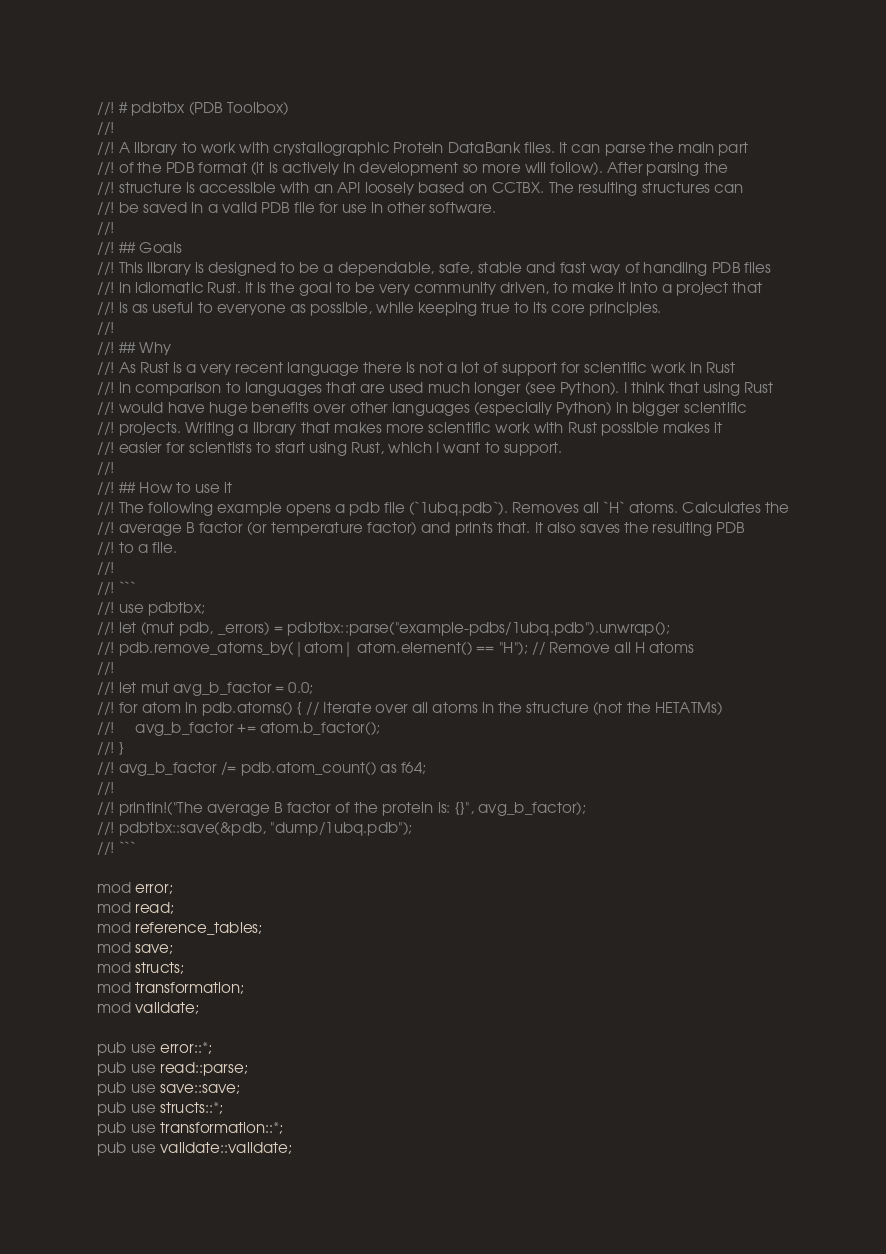<code> <loc_0><loc_0><loc_500><loc_500><_Rust_>//! # pdbtbx (PDB Toolbox)
//!
//! A library to work with crystallographic Protein DataBank files. It can parse the main part
//! of the PDB format (it is actively in development so more will follow). After parsing the
//! structure is accessible with an API loosely based on CCTBX. The resulting structures can
//! be saved in a valid PDB file for use in other software.
//!
//! ## Goals
//! This library is designed to be a dependable, safe, stable and fast way of handling PDB files
//! in idiomatic Rust. It is the goal to be very community driven, to make it into a project that
//! is as useful to everyone as possible, while keeping true to its core principles.
//!
//! ## Why
//! As Rust is a very recent language there is not a lot of support for scientific work in Rust
//! in comparison to languages that are used much longer (see Python). I think that using Rust
//! would have huge benefits over other languages (especially Python) in bigger scientific
//! projects. Writing a library that makes more scientific work with Rust possible makes it
//! easier for scientists to start using Rust, which I want to support.
//!
//! ## How to use it
//! The following example opens a pdb file (`1ubq.pdb`). Removes all `H` atoms. Calculates the
//! average B factor (or temperature factor) and prints that. It also saves the resulting PDB
//! to a file.
//!
//! ```
//! use pdbtbx;
//! let (mut pdb, _errors) = pdbtbx::parse("example-pdbs/1ubq.pdb").unwrap();
//! pdb.remove_atoms_by(|atom| atom.element() == "H"); // Remove all H atoms
//!
//! let mut avg_b_factor = 0.0;
//! for atom in pdb.atoms() { // Iterate over all atoms in the structure (not the HETATMs)
//!     avg_b_factor += atom.b_factor();
//! }
//! avg_b_factor /= pdb.atom_count() as f64;
//!
//! println!("The average B factor of the protein is: {}", avg_b_factor);
//! pdbtbx::save(&pdb, "dump/1ubq.pdb");
//! ```

mod error;
mod read;
mod reference_tables;
mod save;
mod structs;
mod transformation;
mod validate;

pub use error::*;
pub use read::parse;
pub use save::save;
pub use structs::*;
pub use transformation::*;
pub use validate::validate;
</code> 